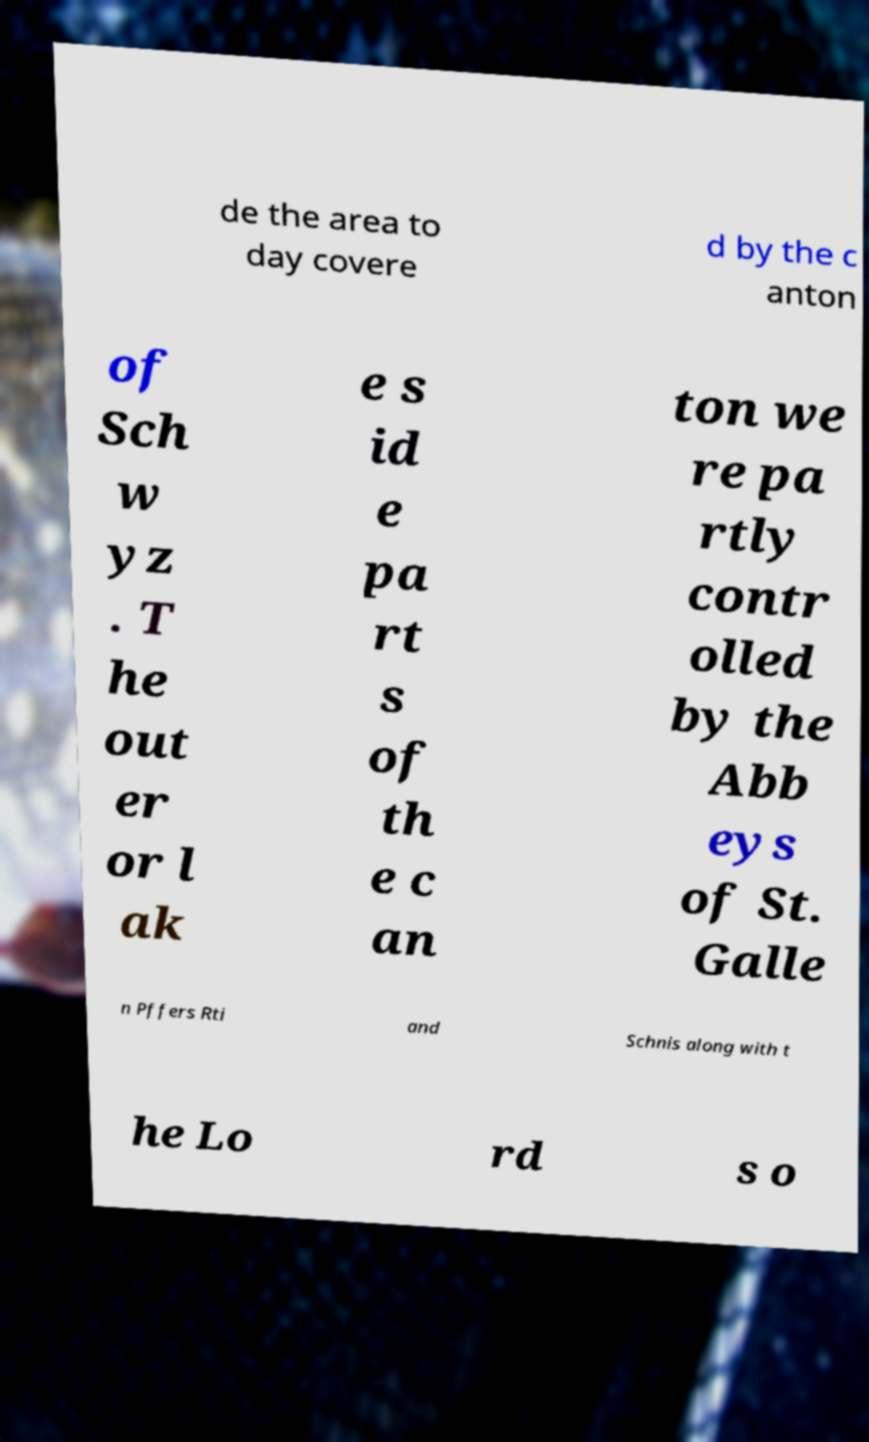Can you read and provide the text displayed in the image?This photo seems to have some interesting text. Can you extract and type it out for me? de the area to day covere d by the c anton of Sch w yz . T he out er or l ak e s id e pa rt s of th e c an ton we re pa rtly contr olled by the Abb eys of St. Galle n Pffers Rti and Schnis along with t he Lo rd s o 